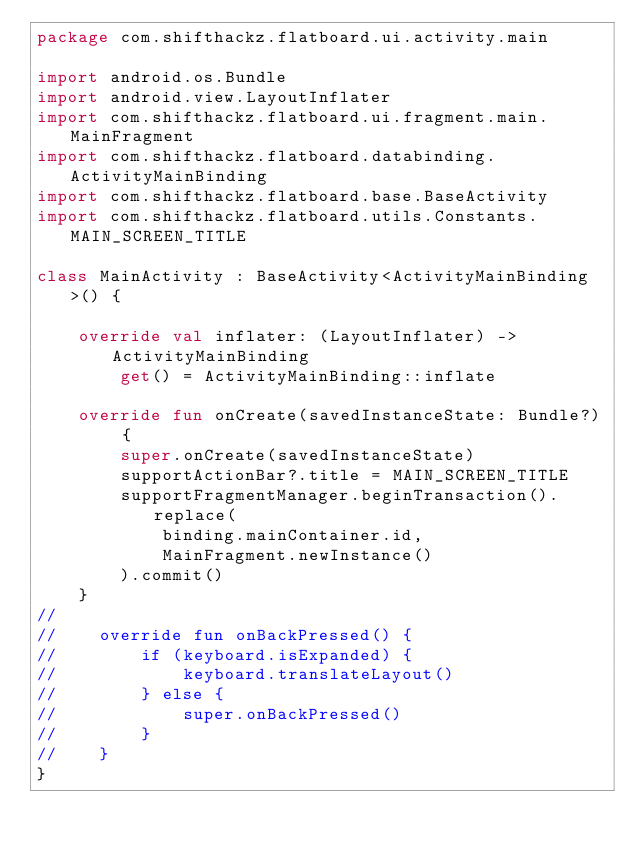Convert code to text. <code><loc_0><loc_0><loc_500><loc_500><_Kotlin_>package com.shifthackz.flatboard.ui.activity.main

import android.os.Bundle
import android.view.LayoutInflater
import com.shifthackz.flatboard.ui.fragment.main.MainFragment
import com.shifthackz.flatboard.databinding.ActivityMainBinding
import com.shifthackz.flatboard.base.BaseActivity
import com.shifthackz.flatboard.utils.Constants.MAIN_SCREEN_TITLE

class MainActivity : BaseActivity<ActivityMainBinding>() {

    override val inflater: (LayoutInflater) -> ActivityMainBinding
        get() = ActivityMainBinding::inflate

    override fun onCreate(savedInstanceState: Bundle?) {
        super.onCreate(savedInstanceState)
        supportActionBar?.title = MAIN_SCREEN_TITLE
        supportFragmentManager.beginTransaction().replace(
            binding.mainContainer.id,
            MainFragment.newInstance()
        ).commit()
    }
//
//    override fun onBackPressed() {
//        if (keyboard.isExpanded) {
//            keyboard.translateLayout()
//        } else {
//            super.onBackPressed()
//        }
//    }
}</code> 